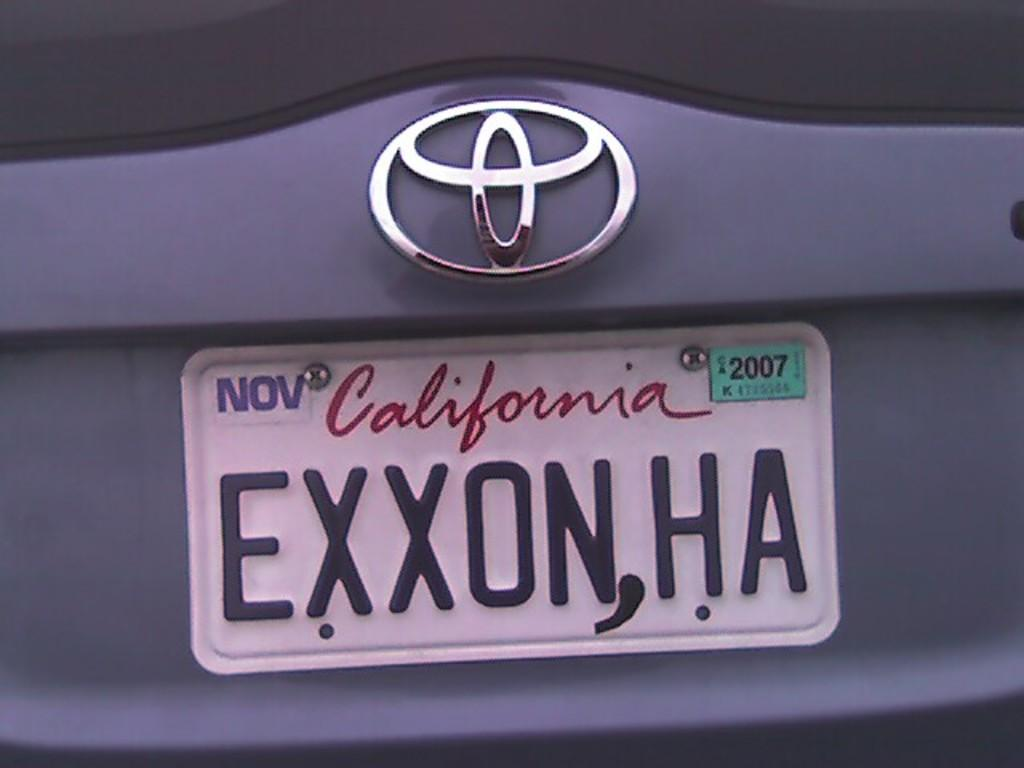<image>
Relay a brief, clear account of the picture shown. A Toyota car has a California license plate that reads EXXONHA. 